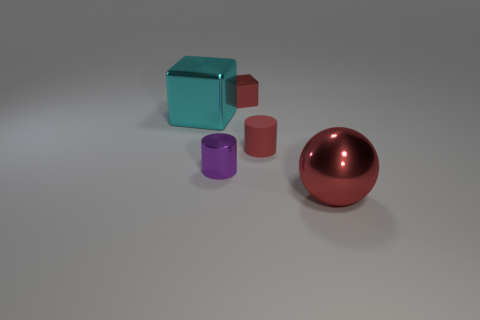Is the number of tiny cylinders that are behind the purple cylinder less than the number of purple cylinders that are behind the red matte thing?
Offer a terse response. No. The tiny thing that is both in front of the red block and on the left side of the rubber thing has what shape?
Your answer should be compact. Cylinder. What number of other small metal things have the same shape as the cyan metal thing?
Make the answer very short. 1. There is a red cube that is made of the same material as the tiny purple thing; what is its size?
Your response must be concise. Small. How many blue metallic cylinders have the same size as the purple shiny thing?
Your answer should be very brief. 0. The shiny sphere that is the same color as the rubber cylinder is what size?
Your answer should be very brief. Large. There is a cube that is to the left of the small shiny object behind the large cyan cube; what is its color?
Provide a succinct answer. Cyan. Are there any tiny rubber cylinders that have the same color as the small matte object?
Keep it short and to the point. No. There is another object that is the same size as the cyan shiny thing; what color is it?
Give a very brief answer. Red. Is the large thing right of the rubber object made of the same material as the small purple object?
Offer a terse response. Yes. 